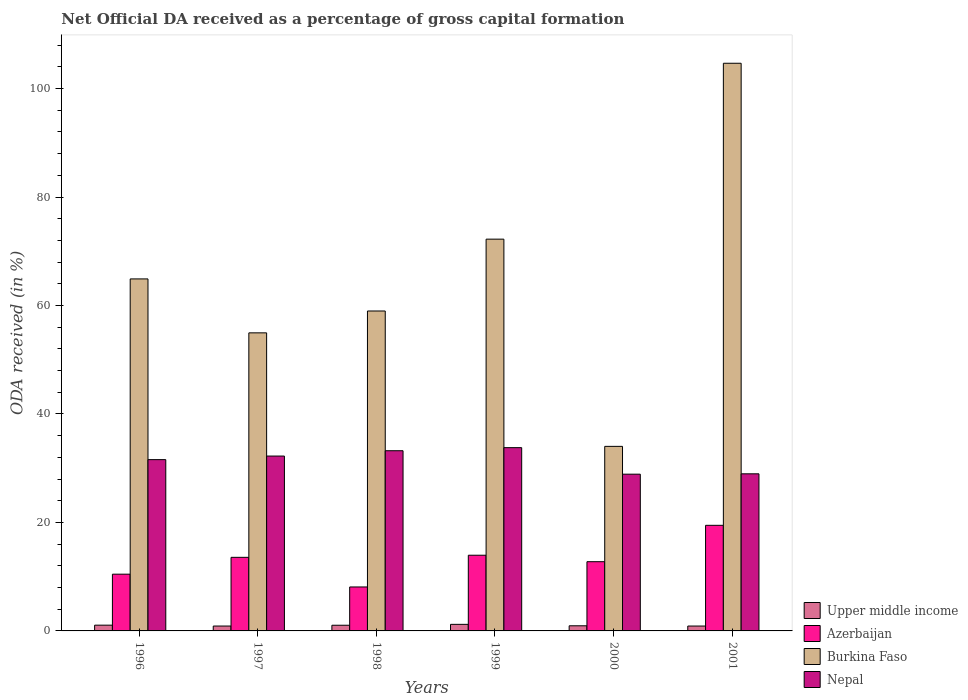How many different coloured bars are there?
Offer a very short reply. 4. How many groups of bars are there?
Your response must be concise. 6. What is the net ODA received in Upper middle income in 1997?
Your answer should be compact. 0.9. Across all years, what is the maximum net ODA received in Nepal?
Your response must be concise. 33.79. Across all years, what is the minimum net ODA received in Nepal?
Offer a very short reply. 28.9. In which year was the net ODA received in Azerbaijan maximum?
Your answer should be very brief. 2001. In which year was the net ODA received in Upper middle income minimum?
Provide a succinct answer. 1997. What is the total net ODA received in Azerbaijan in the graph?
Offer a terse response. 78.32. What is the difference between the net ODA received in Burkina Faso in 1997 and that in 1999?
Keep it short and to the point. -17.28. What is the difference between the net ODA received in Azerbaijan in 2000 and the net ODA received in Upper middle income in 1997?
Provide a succinct answer. 11.86. What is the average net ODA received in Azerbaijan per year?
Your answer should be compact. 13.05. In the year 1996, what is the difference between the net ODA received in Burkina Faso and net ODA received in Upper middle income?
Your answer should be very brief. 63.84. What is the ratio of the net ODA received in Azerbaijan in 1996 to that in 1997?
Give a very brief answer. 0.77. What is the difference between the highest and the second highest net ODA received in Azerbaijan?
Offer a very short reply. 5.51. What is the difference between the highest and the lowest net ODA received in Azerbaijan?
Provide a succinct answer. 11.37. Is it the case that in every year, the sum of the net ODA received in Nepal and net ODA received in Upper middle income is greater than the sum of net ODA received in Burkina Faso and net ODA received in Azerbaijan?
Keep it short and to the point. Yes. What does the 4th bar from the left in 1998 represents?
Your response must be concise. Nepal. What does the 4th bar from the right in 2000 represents?
Provide a short and direct response. Upper middle income. Is it the case that in every year, the sum of the net ODA received in Upper middle income and net ODA received in Burkina Faso is greater than the net ODA received in Nepal?
Your answer should be very brief. Yes. Are all the bars in the graph horizontal?
Provide a short and direct response. No. Does the graph contain any zero values?
Offer a terse response. No. Where does the legend appear in the graph?
Offer a terse response. Bottom right. How many legend labels are there?
Keep it short and to the point. 4. What is the title of the graph?
Make the answer very short. Net Official DA received as a percentage of gross capital formation. Does "Angola" appear as one of the legend labels in the graph?
Your response must be concise. No. What is the label or title of the X-axis?
Ensure brevity in your answer.  Years. What is the label or title of the Y-axis?
Your answer should be compact. ODA received (in %). What is the ODA received (in %) of Upper middle income in 1996?
Offer a terse response. 1.06. What is the ODA received (in %) of Azerbaijan in 1996?
Your answer should be compact. 10.46. What is the ODA received (in %) of Burkina Faso in 1996?
Provide a short and direct response. 64.9. What is the ODA received (in %) of Nepal in 1996?
Offer a terse response. 31.58. What is the ODA received (in %) of Upper middle income in 1997?
Make the answer very short. 0.9. What is the ODA received (in %) in Azerbaijan in 1997?
Ensure brevity in your answer.  13.57. What is the ODA received (in %) in Burkina Faso in 1997?
Ensure brevity in your answer.  54.96. What is the ODA received (in %) of Nepal in 1997?
Make the answer very short. 32.24. What is the ODA received (in %) in Upper middle income in 1998?
Offer a terse response. 1.05. What is the ODA received (in %) in Azerbaijan in 1998?
Your answer should be compact. 8.1. What is the ODA received (in %) of Burkina Faso in 1998?
Your response must be concise. 58.98. What is the ODA received (in %) of Nepal in 1998?
Provide a succinct answer. 33.22. What is the ODA received (in %) in Upper middle income in 1999?
Provide a succinct answer. 1.21. What is the ODA received (in %) of Azerbaijan in 1999?
Provide a short and direct response. 13.96. What is the ODA received (in %) of Burkina Faso in 1999?
Ensure brevity in your answer.  72.23. What is the ODA received (in %) in Nepal in 1999?
Offer a very short reply. 33.79. What is the ODA received (in %) of Upper middle income in 2000?
Make the answer very short. 0.95. What is the ODA received (in %) in Azerbaijan in 2000?
Provide a succinct answer. 12.76. What is the ODA received (in %) of Burkina Faso in 2000?
Give a very brief answer. 34.03. What is the ODA received (in %) of Nepal in 2000?
Offer a terse response. 28.9. What is the ODA received (in %) in Upper middle income in 2001?
Provide a succinct answer. 0.9. What is the ODA received (in %) in Azerbaijan in 2001?
Keep it short and to the point. 19.47. What is the ODA received (in %) in Burkina Faso in 2001?
Make the answer very short. 104.66. What is the ODA received (in %) of Nepal in 2001?
Offer a very short reply. 28.97. Across all years, what is the maximum ODA received (in %) of Upper middle income?
Provide a succinct answer. 1.21. Across all years, what is the maximum ODA received (in %) of Azerbaijan?
Your response must be concise. 19.47. Across all years, what is the maximum ODA received (in %) in Burkina Faso?
Give a very brief answer. 104.66. Across all years, what is the maximum ODA received (in %) in Nepal?
Keep it short and to the point. 33.79. Across all years, what is the minimum ODA received (in %) of Upper middle income?
Your response must be concise. 0.9. Across all years, what is the minimum ODA received (in %) of Azerbaijan?
Keep it short and to the point. 8.1. Across all years, what is the minimum ODA received (in %) of Burkina Faso?
Keep it short and to the point. 34.03. Across all years, what is the minimum ODA received (in %) of Nepal?
Provide a short and direct response. 28.9. What is the total ODA received (in %) in Upper middle income in the graph?
Your answer should be very brief. 6.06. What is the total ODA received (in %) in Azerbaijan in the graph?
Keep it short and to the point. 78.32. What is the total ODA received (in %) of Burkina Faso in the graph?
Make the answer very short. 389.76. What is the total ODA received (in %) in Nepal in the graph?
Keep it short and to the point. 188.7. What is the difference between the ODA received (in %) in Upper middle income in 1996 and that in 1997?
Provide a short and direct response. 0.16. What is the difference between the ODA received (in %) in Azerbaijan in 1996 and that in 1997?
Provide a succinct answer. -3.11. What is the difference between the ODA received (in %) in Burkina Faso in 1996 and that in 1997?
Your response must be concise. 9.94. What is the difference between the ODA received (in %) of Nepal in 1996 and that in 1997?
Your answer should be very brief. -0.66. What is the difference between the ODA received (in %) in Upper middle income in 1996 and that in 1998?
Make the answer very short. 0.02. What is the difference between the ODA received (in %) in Azerbaijan in 1996 and that in 1998?
Your response must be concise. 2.36. What is the difference between the ODA received (in %) of Burkina Faso in 1996 and that in 1998?
Make the answer very short. 5.92. What is the difference between the ODA received (in %) in Nepal in 1996 and that in 1998?
Provide a short and direct response. -1.64. What is the difference between the ODA received (in %) of Upper middle income in 1996 and that in 1999?
Offer a very short reply. -0.15. What is the difference between the ODA received (in %) of Azerbaijan in 1996 and that in 1999?
Keep it short and to the point. -3.5. What is the difference between the ODA received (in %) in Burkina Faso in 1996 and that in 1999?
Make the answer very short. -7.33. What is the difference between the ODA received (in %) in Nepal in 1996 and that in 1999?
Your response must be concise. -2.21. What is the difference between the ODA received (in %) of Upper middle income in 1996 and that in 2000?
Your response must be concise. 0.12. What is the difference between the ODA received (in %) of Azerbaijan in 1996 and that in 2000?
Provide a short and direct response. -2.3. What is the difference between the ODA received (in %) of Burkina Faso in 1996 and that in 2000?
Your answer should be very brief. 30.87. What is the difference between the ODA received (in %) in Nepal in 1996 and that in 2000?
Give a very brief answer. 2.68. What is the difference between the ODA received (in %) in Upper middle income in 1996 and that in 2001?
Offer a very short reply. 0.16. What is the difference between the ODA received (in %) of Azerbaijan in 1996 and that in 2001?
Your answer should be very brief. -9.01. What is the difference between the ODA received (in %) in Burkina Faso in 1996 and that in 2001?
Provide a short and direct response. -39.76. What is the difference between the ODA received (in %) in Nepal in 1996 and that in 2001?
Give a very brief answer. 2.61. What is the difference between the ODA received (in %) of Upper middle income in 1997 and that in 1998?
Offer a very short reply. -0.15. What is the difference between the ODA received (in %) in Azerbaijan in 1997 and that in 1998?
Make the answer very short. 5.46. What is the difference between the ODA received (in %) of Burkina Faso in 1997 and that in 1998?
Your answer should be compact. -4.03. What is the difference between the ODA received (in %) of Nepal in 1997 and that in 1998?
Offer a terse response. -0.98. What is the difference between the ODA received (in %) of Upper middle income in 1997 and that in 1999?
Offer a very short reply. -0.31. What is the difference between the ODA received (in %) of Azerbaijan in 1997 and that in 1999?
Your answer should be very brief. -0.39. What is the difference between the ODA received (in %) in Burkina Faso in 1997 and that in 1999?
Make the answer very short. -17.28. What is the difference between the ODA received (in %) in Nepal in 1997 and that in 1999?
Make the answer very short. -1.55. What is the difference between the ODA received (in %) in Upper middle income in 1997 and that in 2000?
Ensure brevity in your answer.  -0.05. What is the difference between the ODA received (in %) in Azerbaijan in 1997 and that in 2000?
Provide a short and direct response. 0.8. What is the difference between the ODA received (in %) in Burkina Faso in 1997 and that in 2000?
Your answer should be compact. 20.93. What is the difference between the ODA received (in %) of Nepal in 1997 and that in 2000?
Your response must be concise. 3.34. What is the difference between the ODA received (in %) in Upper middle income in 1997 and that in 2001?
Provide a succinct answer. -0. What is the difference between the ODA received (in %) in Azerbaijan in 1997 and that in 2001?
Give a very brief answer. -5.9. What is the difference between the ODA received (in %) in Burkina Faso in 1997 and that in 2001?
Provide a succinct answer. -49.71. What is the difference between the ODA received (in %) of Nepal in 1997 and that in 2001?
Offer a very short reply. 3.28. What is the difference between the ODA received (in %) in Upper middle income in 1998 and that in 1999?
Give a very brief answer. -0.17. What is the difference between the ODA received (in %) in Azerbaijan in 1998 and that in 1999?
Make the answer very short. -5.85. What is the difference between the ODA received (in %) of Burkina Faso in 1998 and that in 1999?
Provide a succinct answer. -13.25. What is the difference between the ODA received (in %) of Nepal in 1998 and that in 1999?
Keep it short and to the point. -0.57. What is the difference between the ODA received (in %) of Upper middle income in 1998 and that in 2000?
Offer a very short reply. 0.1. What is the difference between the ODA received (in %) in Azerbaijan in 1998 and that in 2000?
Your answer should be compact. -4.66. What is the difference between the ODA received (in %) of Burkina Faso in 1998 and that in 2000?
Provide a short and direct response. 24.96. What is the difference between the ODA received (in %) of Nepal in 1998 and that in 2000?
Your response must be concise. 4.32. What is the difference between the ODA received (in %) in Upper middle income in 1998 and that in 2001?
Ensure brevity in your answer.  0.15. What is the difference between the ODA received (in %) of Azerbaijan in 1998 and that in 2001?
Your response must be concise. -11.37. What is the difference between the ODA received (in %) in Burkina Faso in 1998 and that in 2001?
Offer a terse response. -45.68. What is the difference between the ODA received (in %) of Nepal in 1998 and that in 2001?
Keep it short and to the point. 4.26. What is the difference between the ODA received (in %) of Upper middle income in 1999 and that in 2000?
Provide a short and direct response. 0.27. What is the difference between the ODA received (in %) of Azerbaijan in 1999 and that in 2000?
Provide a short and direct response. 1.19. What is the difference between the ODA received (in %) of Burkina Faso in 1999 and that in 2000?
Provide a succinct answer. 38.21. What is the difference between the ODA received (in %) of Nepal in 1999 and that in 2000?
Ensure brevity in your answer.  4.89. What is the difference between the ODA received (in %) in Upper middle income in 1999 and that in 2001?
Keep it short and to the point. 0.31. What is the difference between the ODA received (in %) in Azerbaijan in 1999 and that in 2001?
Give a very brief answer. -5.51. What is the difference between the ODA received (in %) in Burkina Faso in 1999 and that in 2001?
Provide a short and direct response. -32.43. What is the difference between the ODA received (in %) in Nepal in 1999 and that in 2001?
Your response must be concise. 4.82. What is the difference between the ODA received (in %) of Upper middle income in 2000 and that in 2001?
Ensure brevity in your answer.  0.04. What is the difference between the ODA received (in %) of Azerbaijan in 2000 and that in 2001?
Keep it short and to the point. -6.71. What is the difference between the ODA received (in %) of Burkina Faso in 2000 and that in 2001?
Keep it short and to the point. -70.63. What is the difference between the ODA received (in %) of Nepal in 2000 and that in 2001?
Your answer should be very brief. -0.07. What is the difference between the ODA received (in %) of Upper middle income in 1996 and the ODA received (in %) of Azerbaijan in 1997?
Provide a short and direct response. -12.51. What is the difference between the ODA received (in %) in Upper middle income in 1996 and the ODA received (in %) in Burkina Faso in 1997?
Keep it short and to the point. -53.9. What is the difference between the ODA received (in %) of Upper middle income in 1996 and the ODA received (in %) of Nepal in 1997?
Your answer should be very brief. -31.18. What is the difference between the ODA received (in %) in Azerbaijan in 1996 and the ODA received (in %) in Burkina Faso in 1997?
Your answer should be very brief. -44.5. What is the difference between the ODA received (in %) in Azerbaijan in 1996 and the ODA received (in %) in Nepal in 1997?
Offer a terse response. -21.78. What is the difference between the ODA received (in %) in Burkina Faso in 1996 and the ODA received (in %) in Nepal in 1997?
Ensure brevity in your answer.  32.66. What is the difference between the ODA received (in %) in Upper middle income in 1996 and the ODA received (in %) in Azerbaijan in 1998?
Ensure brevity in your answer.  -7.04. What is the difference between the ODA received (in %) in Upper middle income in 1996 and the ODA received (in %) in Burkina Faso in 1998?
Offer a very short reply. -57.92. What is the difference between the ODA received (in %) in Upper middle income in 1996 and the ODA received (in %) in Nepal in 1998?
Provide a short and direct response. -32.16. What is the difference between the ODA received (in %) of Azerbaijan in 1996 and the ODA received (in %) of Burkina Faso in 1998?
Ensure brevity in your answer.  -48.52. What is the difference between the ODA received (in %) of Azerbaijan in 1996 and the ODA received (in %) of Nepal in 1998?
Give a very brief answer. -22.76. What is the difference between the ODA received (in %) in Burkina Faso in 1996 and the ODA received (in %) in Nepal in 1998?
Provide a succinct answer. 31.68. What is the difference between the ODA received (in %) in Upper middle income in 1996 and the ODA received (in %) in Azerbaijan in 1999?
Your answer should be very brief. -12.9. What is the difference between the ODA received (in %) in Upper middle income in 1996 and the ODA received (in %) in Burkina Faso in 1999?
Give a very brief answer. -71.17. What is the difference between the ODA received (in %) of Upper middle income in 1996 and the ODA received (in %) of Nepal in 1999?
Keep it short and to the point. -32.73. What is the difference between the ODA received (in %) of Azerbaijan in 1996 and the ODA received (in %) of Burkina Faso in 1999?
Give a very brief answer. -61.77. What is the difference between the ODA received (in %) of Azerbaijan in 1996 and the ODA received (in %) of Nepal in 1999?
Give a very brief answer. -23.33. What is the difference between the ODA received (in %) in Burkina Faso in 1996 and the ODA received (in %) in Nepal in 1999?
Keep it short and to the point. 31.11. What is the difference between the ODA received (in %) in Upper middle income in 1996 and the ODA received (in %) in Azerbaijan in 2000?
Keep it short and to the point. -11.7. What is the difference between the ODA received (in %) of Upper middle income in 1996 and the ODA received (in %) of Burkina Faso in 2000?
Keep it short and to the point. -32.97. What is the difference between the ODA received (in %) of Upper middle income in 1996 and the ODA received (in %) of Nepal in 2000?
Your answer should be compact. -27.84. What is the difference between the ODA received (in %) in Azerbaijan in 1996 and the ODA received (in %) in Burkina Faso in 2000?
Make the answer very short. -23.57. What is the difference between the ODA received (in %) in Azerbaijan in 1996 and the ODA received (in %) in Nepal in 2000?
Provide a short and direct response. -18.44. What is the difference between the ODA received (in %) of Burkina Faso in 1996 and the ODA received (in %) of Nepal in 2000?
Your answer should be compact. 36. What is the difference between the ODA received (in %) in Upper middle income in 1996 and the ODA received (in %) in Azerbaijan in 2001?
Provide a succinct answer. -18.41. What is the difference between the ODA received (in %) in Upper middle income in 1996 and the ODA received (in %) in Burkina Faso in 2001?
Make the answer very short. -103.6. What is the difference between the ODA received (in %) of Upper middle income in 1996 and the ODA received (in %) of Nepal in 2001?
Offer a terse response. -27.9. What is the difference between the ODA received (in %) in Azerbaijan in 1996 and the ODA received (in %) in Burkina Faso in 2001?
Make the answer very short. -94.2. What is the difference between the ODA received (in %) in Azerbaijan in 1996 and the ODA received (in %) in Nepal in 2001?
Your answer should be compact. -18.51. What is the difference between the ODA received (in %) in Burkina Faso in 1996 and the ODA received (in %) in Nepal in 2001?
Provide a succinct answer. 35.93. What is the difference between the ODA received (in %) in Upper middle income in 1997 and the ODA received (in %) in Azerbaijan in 1998?
Provide a succinct answer. -7.21. What is the difference between the ODA received (in %) in Upper middle income in 1997 and the ODA received (in %) in Burkina Faso in 1998?
Offer a terse response. -58.09. What is the difference between the ODA received (in %) in Upper middle income in 1997 and the ODA received (in %) in Nepal in 1998?
Provide a succinct answer. -32.32. What is the difference between the ODA received (in %) in Azerbaijan in 1997 and the ODA received (in %) in Burkina Faso in 1998?
Your response must be concise. -45.42. What is the difference between the ODA received (in %) of Azerbaijan in 1997 and the ODA received (in %) of Nepal in 1998?
Your response must be concise. -19.66. What is the difference between the ODA received (in %) of Burkina Faso in 1997 and the ODA received (in %) of Nepal in 1998?
Your response must be concise. 21.73. What is the difference between the ODA received (in %) in Upper middle income in 1997 and the ODA received (in %) in Azerbaijan in 1999?
Your response must be concise. -13.06. What is the difference between the ODA received (in %) of Upper middle income in 1997 and the ODA received (in %) of Burkina Faso in 1999?
Offer a terse response. -71.33. What is the difference between the ODA received (in %) in Upper middle income in 1997 and the ODA received (in %) in Nepal in 1999?
Provide a short and direct response. -32.89. What is the difference between the ODA received (in %) of Azerbaijan in 1997 and the ODA received (in %) of Burkina Faso in 1999?
Give a very brief answer. -58.67. What is the difference between the ODA received (in %) of Azerbaijan in 1997 and the ODA received (in %) of Nepal in 1999?
Provide a succinct answer. -20.22. What is the difference between the ODA received (in %) of Burkina Faso in 1997 and the ODA received (in %) of Nepal in 1999?
Your answer should be compact. 21.17. What is the difference between the ODA received (in %) of Upper middle income in 1997 and the ODA received (in %) of Azerbaijan in 2000?
Your answer should be compact. -11.86. What is the difference between the ODA received (in %) in Upper middle income in 1997 and the ODA received (in %) in Burkina Faso in 2000?
Offer a terse response. -33.13. What is the difference between the ODA received (in %) in Upper middle income in 1997 and the ODA received (in %) in Nepal in 2000?
Give a very brief answer. -28. What is the difference between the ODA received (in %) in Azerbaijan in 1997 and the ODA received (in %) in Burkina Faso in 2000?
Ensure brevity in your answer.  -20.46. What is the difference between the ODA received (in %) of Azerbaijan in 1997 and the ODA received (in %) of Nepal in 2000?
Your answer should be very brief. -15.33. What is the difference between the ODA received (in %) of Burkina Faso in 1997 and the ODA received (in %) of Nepal in 2000?
Make the answer very short. 26.06. What is the difference between the ODA received (in %) of Upper middle income in 1997 and the ODA received (in %) of Azerbaijan in 2001?
Provide a short and direct response. -18.57. What is the difference between the ODA received (in %) in Upper middle income in 1997 and the ODA received (in %) in Burkina Faso in 2001?
Provide a succinct answer. -103.76. What is the difference between the ODA received (in %) in Upper middle income in 1997 and the ODA received (in %) in Nepal in 2001?
Ensure brevity in your answer.  -28.07. What is the difference between the ODA received (in %) in Azerbaijan in 1997 and the ODA received (in %) in Burkina Faso in 2001?
Give a very brief answer. -91.09. What is the difference between the ODA received (in %) of Azerbaijan in 1997 and the ODA received (in %) of Nepal in 2001?
Offer a terse response. -15.4. What is the difference between the ODA received (in %) in Burkina Faso in 1997 and the ODA received (in %) in Nepal in 2001?
Make the answer very short. 25.99. What is the difference between the ODA received (in %) in Upper middle income in 1998 and the ODA received (in %) in Azerbaijan in 1999?
Your answer should be compact. -12.91. What is the difference between the ODA received (in %) in Upper middle income in 1998 and the ODA received (in %) in Burkina Faso in 1999?
Your answer should be compact. -71.19. What is the difference between the ODA received (in %) in Upper middle income in 1998 and the ODA received (in %) in Nepal in 1999?
Offer a very short reply. -32.74. What is the difference between the ODA received (in %) in Azerbaijan in 1998 and the ODA received (in %) in Burkina Faso in 1999?
Provide a succinct answer. -64.13. What is the difference between the ODA received (in %) in Azerbaijan in 1998 and the ODA received (in %) in Nepal in 1999?
Your answer should be very brief. -25.68. What is the difference between the ODA received (in %) of Burkina Faso in 1998 and the ODA received (in %) of Nepal in 1999?
Provide a short and direct response. 25.2. What is the difference between the ODA received (in %) in Upper middle income in 1998 and the ODA received (in %) in Azerbaijan in 2000?
Provide a succinct answer. -11.72. What is the difference between the ODA received (in %) in Upper middle income in 1998 and the ODA received (in %) in Burkina Faso in 2000?
Give a very brief answer. -32.98. What is the difference between the ODA received (in %) of Upper middle income in 1998 and the ODA received (in %) of Nepal in 2000?
Provide a succinct answer. -27.85. What is the difference between the ODA received (in %) in Azerbaijan in 1998 and the ODA received (in %) in Burkina Faso in 2000?
Provide a short and direct response. -25.92. What is the difference between the ODA received (in %) of Azerbaijan in 1998 and the ODA received (in %) of Nepal in 2000?
Your answer should be very brief. -20.79. What is the difference between the ODA received (in %) in Burkina Faso in 1998 and the ODA received (in %) in Nepal in 2000?
Your answer should be very brief. 30.09. What is the difference between the ODA received (in %) of Upper middle income in 1998 and the ODA received (in %) of Azerbaijan in 2001?
Your answer should be very brief. -18.42. What is the difference between the ODA received (in %) of Upper middle income in 1998 and the ODA received (in %) of Burkina Faso in 2001?
Keep it short and to the point. -103.62. What is the difference between the ODA received (in %) in Upper middle income in 1998 and the ODA received (in %) in Nepal in 2001?
Keep it short and to the point. -27.92. What is the difference between the ODA received (in %) of Azerbaijan in 1998 and the ODA received (in %) of Burkina Faso in 2001?
Give a very brief answer. -96.56. What is the difference between the ODA received (in %) of Azerbaijan in 1998 and the ODA received (in %) of Nepal in 2001?
Keep it short and to the point. -20.86. What is the difference between the ODA received (in %) of Burkina Faso in 1998 and the ODA received (in %) of Nepal in 2001?
Your answer should be very brief. 30.02. What is the difference between the ODA received (in %) in Upper middle income in 1999 and the ODA received (in %) in Azerbaijan in 2000?
Offer a terse response. -11.55. What is the difference between the ODA received (in %) of Upper middle income in 1999 and the ODA received (in %) of Burkina Faso in 2000?
Make the answer very short. -32.82. What is the difference between the ODA received (in %) in Upper middle income in 1999 and the ODA received (in %) in Nepal in 2000?
Provide a short and direct response. -27.69. What is the difference between the ODA received (in %) of Azerbaijan in 1999 and the ODA received (in %) of Burkina Faso in 2000?
Give a very brief answer. -20.07. What is the difference between the ODA received (in %) of Azerbaijan in 1999 and the ODA received (in %) of Nepal in 2000?
Provide a short and direct response. -14.94. What is the difference between the ODA received (in %) in Burkina Faso in 1999 and the ODA received (in %) in Nepal in 2000?
Your response must be concise. 43.33. What is the difference between the ODA received (in %) in Upper middle income in 1999 and the ODA received (in %) in Azerbaijan in 2001?
Provide a succinct answer. -18.26. What is the difference between the ODA received (in %) of Upper middle income in 1999 and the ODA received (in %) of Burkina Faso in 2001?
Provide a succinct answer. -103.45. What is the difference between the ODA received (in %) in Upper middle income in 1999 and the ODA received (in %) in Nepal in 2001?
Keep it short and to the point. -27.75. What is the difference between the ODA received (in %) of Azerbaijan in 1999 and the ODA received (in %) of Burkina Faso in 2001?
Your answer should be compact. -90.7. What is the difference between the ODA received (in %) in Azerbaijan in 1999 and the ODA received (in %) in Nepal in 2001?
Keep it short and to the point. -15.01. What is the difference between the ODA received (in %) of Burkina Faso in 1999 and the ODA received (in %) of Nepal in 2001?
Your answer should be very brief. 43.27. What is the difference between the ODA received (in %) in Upper middle income in 2000 and the ODA received (in %) in Azerbaijan in 2001?
Your answer should be very brief. -18.52. What is the difference between the ODA received (in %) in Upper middle income in 2000 and the ODA received (in %) in Burkina Faso in 2001?
Give a very brief answer. -103.72. What is the difference between the ODA received (in %) of Upper middle income in 2000 and the ODA received (in %) of Nepal in 2001?
Your answer should be compact. -28.02. What is the difference between the ODA received (in %) in Azerbaijan in 2000 and the ODA received (in %) in Burkina Faso in 2001?
Provide a short and direct response. -91.9. What is the difference between the ODA received (in %) of Azerbaijan in 2000 and the ODA received (in %) of Nepal in 2001?
Provide a succinct answer. -16.2. What is the difference between the ODA received (in %) of Burkina Faso in 2000 and the ODA received (in %) of Nepal in 2001?
Offer a very short reply. 5.06. What is the average ODA received (in %) in Upper middle income per year?
Your answer should be compact. 1.01. What is the average ODA received (in %) of Azerbaijan per year?
Offer a very short reply. 13.05. What is the average ODA received (in %) of Burkina Faso per year?
Provide a succinct answer. 64.96. What is the average ODA received (in %) of Nepal per year?
Keep it short and to the point. 31.45. In the year 1996, what is the difference between the ODA received (in %) in Upper middle income and ODA received (in %) in Azerbaijan?
Your answer should be compact. -9.4. In the year 1996, what is the difference between the ODA received (in %) of Upper middle income and ODA received (in %) of Burkina Faso?
Provide a short and direct response. -63.84. In the year 1996, what is the difference between the ODA received (in %) in Upper middle income and ODA received (in %) in Nepal?
Make the answer very short. -30.52. In the year 1996, what is the difference between the ODA received (in %) of Azerbaijan and ODA received (in %) of Burkina Faso?
Your answer should be very brief. -54.44. In the year 1996, what is the difference between the ODA received (in %) in Azerbaijan and ODA received (in %) in Nepal?
Your response must be concise. -21.12. In the year 1996, what is the difference between the ODA received (in %) in Burkina Faso and ODA received (in %) in Nepal?
Provide a short and direct response. 33.32. In the year 1997, what is the difference between the ODA received (in %) in Upper middle income and ODA received (in %) in Azerbaijan?
Your response must be concise. -12.67. In the year 1997, what is the difference between the ODA received (in %) in Upper middle income and ODA received (in %) in Burkina Faso?
Ensure brevity in your answer.  -54.06. In the year 1997, what is the difference between the ODA received (in %) in Upper middle income and ODA received (in %) in Nepal?
Your answer should be compact. -31.34. In the year 1997, what is the difference between the ODA received (in %) of Azerbaijan and ODA received (in %) of Burkina Faso?
Give a very brief answer. -41.39. In the year 1997, what is the difference between the ODA received (in %) in Azerbaijan and ODA received (in %) in Nepal?
Ensure brevity in your answer.  -18.67. In the year 1997, what is the difference between the ODA received (in %) of Burkina Faso and ODA received (in %) of Nepal?
Your response must be concise. 22.71. In the year 1998, what is the difference between the ODA received (in %) in Upper middle income and ODA received (in %) in Azerbaijan?
Keep it short and to the point. -7.06. In the year 1998, what is the difference between the ODA received (in %) of Upper middle income and ODA received (in %) of Burkina Faso?
Offer a terse response. -57.94. In the year 1998, what is the difference between the ODA received (in %) in Upper middle income and ODA received (in %) in Nepal?
Provide a succinct answer. -32.18. In the year 1998, what is the difference between the ODA received (in %) of Azerbaijan and ODA received (in %) of Burkina Faso?
Provide a succinct answer. -50.88. In the year 1998, what is the difference between the ODA received (in %) in Azerbaijan and ODA received (in %) in Nepal?
Offer a terse response. -25.12. In the year 1998, what is the difference between the ODA received (in %) of Burkina Faso and ODA received (in %) of Nepal?
Ensure brevity in your answer.  25.76. In the year 1999, what is the difference between the ODA received (in %) of Upper middle income and ODA received (in %) of Azerbaijan?
Your answer should be compact. -12.75. In the year 1999, what is the difference between the ODA received (in %) of Upper middle income and ODA received (in %) of Burkina Faso?
Offer a very short reply. -71.02. In the year 1999, what is the difference between the ODA received (in %) in Upper middle income and ODA received (in %) in Nepal?
Give a very brief answer. -32.58. In the year 1999, what is the difference between the ODA received (in %) in Azerbaijan and ODA received (in %) in Burkina Faso?
Ensure brevity in your answer.  -58.28. In the year 1999, what is the difference between the ODA received (in %) of Azerbaijan and ODA received (in %) of Nepal?
Give a very brief answer. -19.83. In the year 1999, what is the difference between the ODA received (in %) in Burkina Faso and ODA received (in %) in Nepal?
Offer a terse response. 38.44. In the year 2000, what is the difference between the ODA received (in %) in Upper middle income and ODA received (in %) in Azerbaijan?
Your answer should be very brief. -11.82. In the year 2000, what is the difference between the ODA received (in %) of Upper middle income and ODA received (in %) of Burkina Faso?
Offer a very short reply. -33.08. In the year 2000, what is the difference between the ODA received (in %) of Upper middle income and ODA received (in %) of Nepal?
Your answer should be very brief. -27.95. In the year 2000, what is the difference between the ODA received (in %) in Azerbaijan and ODA received (in %) in Burkina Faso?
Provide a succinct answer. -21.26. In the year 2000, what is the difference between the ODA received (in %) in Azerbaijan and ODA received (in %) in Nepal?
Keep it short and to the point. -16.14. In the year 2000, what is the difference between the ODA received (in %) in Burkina Faso and ODA received (in %) in Nepal?
Your answer should be compact. 5.13. In the year 2001, what is the difference between the ODA received (in %) in Upper middle income and ODA received (in %) in Azerbaijan?
Make the answer very short. -18.57. In the year 2001, what is the difference between the ODA received (in %) in Upper middle income and ODA received (in %) in Burkina Faso?
Offer a terse response. -103.76. In the year 2001, what is the difference between the ODA received (in %) of Upper middle income and ODA received (in %) of Nepal?
Offer a terse response. -28.07. In the year 2001, what is the difference between the ODA received (in %) in Azerbaijan and ODA received (in %) in Burkina Faso?
Make the answer very short. -85.19. In the year 2001, what is the difference between the ODA received (in %) of Azerbaijan and ODA received (in %) of Nepal?
Your answer should be very brief. -9.5. In the year 2001, what is the difference between the ODA received (in %) in Burkina Faso and ODA received (in %) in Nepal?
Make the answer very short. 75.7. What is the ratio of the ODA received (in %) in Upper middle income in 1996 to that in 1997?
Your answer should be compact. 1.18. What is the ratio of the ODA received (in %) in Azerbaijan in 1996 to that in 1997?
Provide a succinct answer. 0.77. What is the ratio of the ODA received (in %) of Burkina Faso in 1996 to that in 1997?
Make the answer very short. 1.18. What is the ratio of the ODA received (in %) of Nepal in 1996 to that in 1997?
Offer a terse response. 0.98. What is the ratio of the ODA received (in %) in Upper middle income in 1996 to that in 1998?
Your response must be concise. 1.01. What is the ratio of the ODA received (in %) of Azerbaijan in 1996 to that in 1998?
Ensure brevity in your answer.  1.29. What is the ratio of the ODA received (in %) of Burkina Faso in 1996 to that in 1998?
Offer a very short reply. 1.1. What is the ratio of the ODA received (in %) in Nepal in 1996 to that in 1998?
Give a very brief answer. 0.95. What is the ratio of the ODA received (in %) of Upper middle income in 1996 to that in 1999?
Your response must be concise. 0.88. What is the ratio of the ODA received (in %) in Azerbaijan in 1996 to that in 1999?
Your answer should be very brief. 0.75. What is the ratio of the ODA received (in %) in Burkina Faso in 1996 to that in 1999?
Offer a very short reply. 0.9. What is the ratio of the ODA received (in %) in Nepal in 1996 to that in 1999?
Your answer should be compact. 0.93. What is the ratio of the ODA received (in %) in Upper middle income in 1996 to that in 2000?
Provide a short and direct response. 1.12. What is the ratio of the ODA received (in %) of Azerbaijan in 1996 to that in 2000?
Make the answer very short. 0.82. What is the ratio of the ODA received (in %) in Burkina Faso in 1996 to that in 2000?
Provide a succinct answer. 1.91. What is the ratio of the ODA received (in %) in Nepal in 1996 to that in 2000?
Offer a terse response. 1.09. What is the ratio of the ODA received (in %) in Upper middle income in 1996 to that in 2001?
Your answer should be very brief. 1.18. What is the ratio of the ODA received (in %) in Azerbaijan in 1996 to that in 2001?
Your answer should be compact. 0.54. What is the ratio of the ODA received (in %) in Burkina Faso in 1996 to that in 2001?
Provide a succinct answer. 0.62. What is the ratio of the ODA received (in %) of Nepal in 1996 to that in 2001?
Give a very brief answer. 1.09. What is the ratio of the ODA received (in %) in Upper middle income in 1997 to that in 1998?
Ensure brevity in your answer.  0.86. What is the ratio of the ODA received (in %) of Azerbaijan in 1997 to that in 1998?
Make the answer very short. 1.67. What is the ratio of the ODA received (in %) of Burkina Faso in 1997 to that in 1998?
Keep it short and to the point. 0.93. What is the ratio of the ODA received (in %) in Nepal in 1997 to that in 1998?
Offer a terse response. 0.97. What is the ratio of the ODA received (in %) in Upper middle income in 1997 to that in 1999?
Your response must be concise. 0.74. What is the ratio of the ODA received (in %) in Azerbaijan in 1997 to that in 1999?
Provide a short and direct response. 0.97. What is the ratio of the ODA received (in %) of Burkina Faso in 1997 to that in 1999?
Your answer should be compact. 0.76. What is the ratio of the ODA received (in %) in Nepal in 1997 to that in 1999?
Give a very brief answer. 0.95. What is the ratio of the ODA received (in %) in Upper middle income in 1997 to that in 2000?
Provide a succinct answer. 0.95. What is the ratio of the ODA received (in %) in Azerbaijan in 1997 to that in 2000?
Keep it short and to the point. 1.06. What is the ratio of the ODA received (in %) of Burkina Faso in 1997 to that in 2000?
Your answer should be very brief. 1.62. What is the ratio of the ODA received (in %) of Nepal in 1997 to that in 2000?
Keep it short and to the point. 1.12. What is the ratio of the ODA received (in %) in Upper middle income in 1997 to that in 2001?
Keep it short and to the point. 1. What is the ratio of the ODA received (in %) in Azerbaijan in 1997 to that in 2001?
Your response must be concise. 0.7. What is the ratio of the ODA received (in %) in Burkina Faso in 1997 to that in 2001?
Give a very brief answer. 0.53. What is the ratio of the ODA received (in %) in Nepal in 1997 to that in 2001?
Your answer should be compact. 1.11. What is the ratio of the ODA received (in %) of Upper middle income in 1998 to that in 1999?
Provide a succinct answer. 0.86. What is the ratio of the ODA received (in %) of Azerbaijan in 1998 to that in 1999?
Provide a succinct answer. 0.58. What is the ratio of the ODA received (in %) in Burkina Faso in 1998 to that in 1999?
Offer a very short reply. 0.82. What is the ratio of the ODA received (in %) in Nepal in 1998 to that in 1999?
Keep it short and to the point. 0.98. What is the ratio of the ODA received (in %) of Upper middle income in 1998 to that in 2000?
Your answer should be very brief. 1.11. What is the ratio of the ODA received (in %) in Azerbaijan in 1998 to that in 2000?
Offer a terse response. 0.64. What is the ratio of the ODA received (in %) in Burkina Faso in 1998 to that in 2000?
Make the answer very short. 1.73. What is the ratio of the ODA received (in %) in Nepal in 1998 to that in 2000?
Give a very brief answer. 1.15. What is the ratio of the ODA received (in %) in Upper middle income in 1998 to that in 2001?
Ensure brevity in your answer.  1.16. What is the ratio of the ODA received (in %) in Azerbaijan in 1998 to that in 2001?
Your answer should be very brief. 0.42. What is the ratio of the ODA received (in %) in Burkina Faso in 1998 to that in 2001?
Your answer should be very brief. 0.56. What is the ratio of the ODA received (in %) in Nepal in 1998 to that in 2001?
Ensure brevity in your answer.  1.15. What is the ratio of the ODA received (in %) of Upper middle income in 1999 to that in 2000?
Give a very brief answer. 1.28. What is the ratio of the ODA received (in %) in Azerbaijan in 1999 to that in 2000?
Your answer should be very brief. 1.09. What is the ratio of the ODA received (in %) in Burkina Faso in 1999 to that in 2000?
Provide a succinct answer. 2.12. What is the ratio of the ODA received (in %) in Nepal in 1999 to that in 2000?
Keep it short and to the point. 1.17. What is the ratio of the ODA received (in %) in Upper middle income in 1999 to that in 2001?
Give a very brief answer. 1.35. What is the ratio of the ODA received (in %) in Azerbaijan in 1999 to that in 2001?
Keep it short and to the point. 0.72. What is the ratio of the ODA received (in %) in Burkina Faso in 1999 to that in 2001?
Make the answer very short. 0.69. What is the ratio of the ODA received (in %) in Nepal in 1999 to that in 2001?
Your answer should be compact. 1.17. What is the ratio of the ODA received (in %) in Upper middle income in 2000 to that in 2001?
Give a very brief answer. 1.05. What is the ratio of the ODA received (in %) of Azerbaijan in 2000 to that in 2001?
Offer a very short reply. 0.66. What is the ratio of the ODA received (in %) in Burkina Faso in 2000 to that in 2001?
Offer a terse response. 0.33. What is the difference between the highest and the second highest ODA received (in %) of Upper middle income?
Provide a succinct answer. 0.15. What is the difference between the highest and the second highest ODA received (in %) of Azerbaijan?
Give a very brief answer. 5.51. What is the difference between the highest and the second highest ODA received (in %) of Burkina Faso?
Keep it short and to the point. 32.43. What is the difference between the highest and the second highest ODA received (in %) of Nepal?
Provide a short and direct response. 0.57. What is the difference between the highest and the lowest ODA received (in %) of Upper middle income?
Ensure brevity in your answer.  0.31. What is the difference between the highest and the lowest ODA received (in %) in Azerbaijan?
Keep it short and to the point. 11.37. What is the difference between the highest and the lowest ODA received (in %) in Burkina Faso?
Offer a terse response. 70.63. What is the difference between the highest and the lowest ODA received (in %) of Nepal?
Keep it short and to the point. 4.89. 